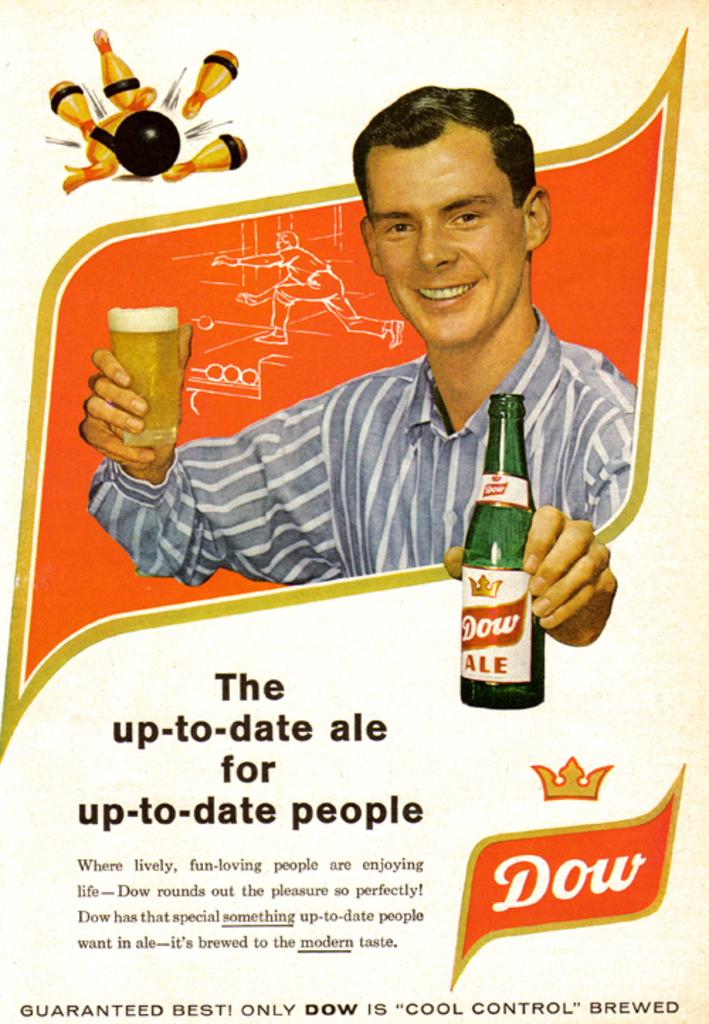<image>
Present a compact description of the photo's key features. An advertisement from Dow ale for up-to-date people. 